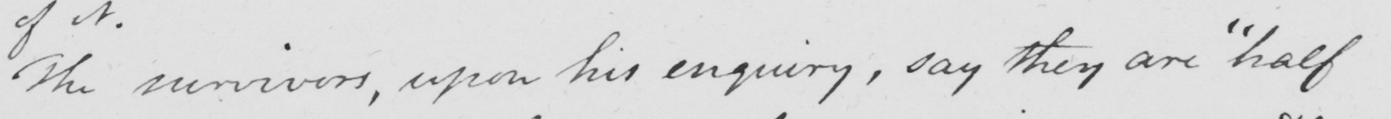Can you tell me what this handwritten text says? The survivors , upon his enquiry , say they are  " half 